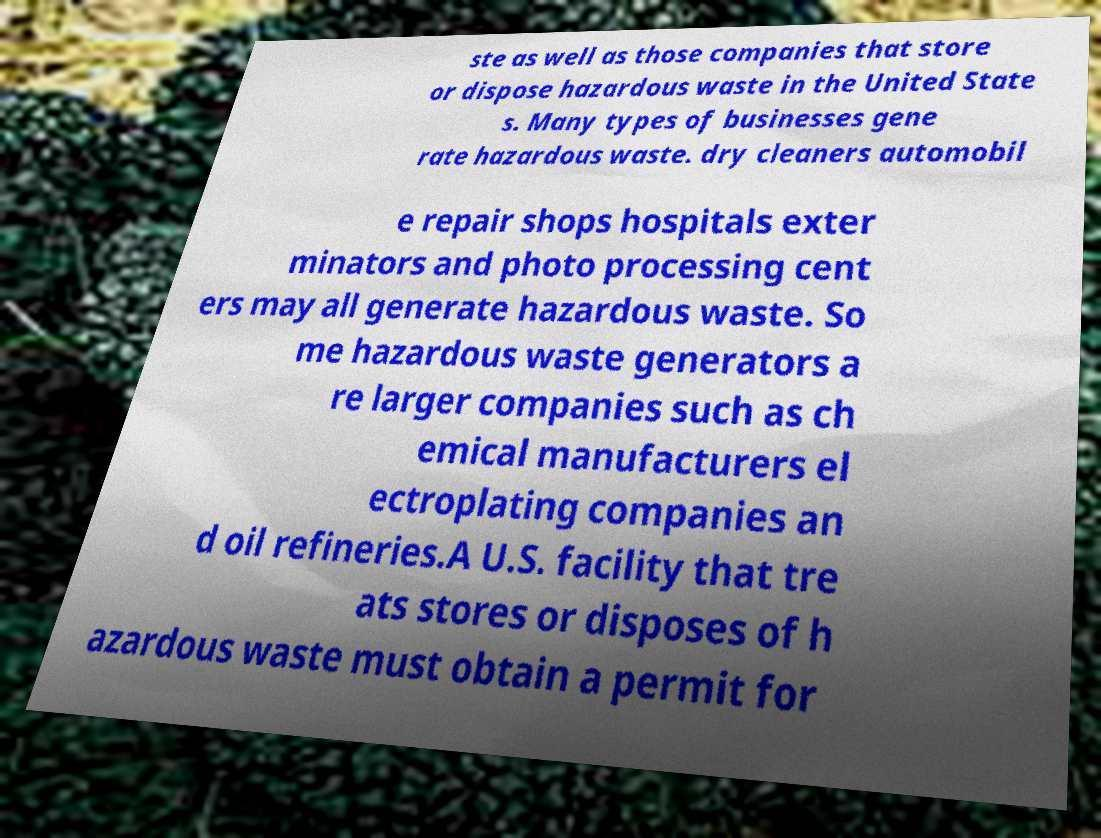Can you accurately transcribe the text from the provided image for me? ste as well as those companies that store or dispose hazardous waste in the United State s. Many types of businesses gene rate hazardous waste. dry cleaners automobil e repair shops hospitals exter minators and photo processing cent ers may all generate hazardous waste. So me hazardous waste generators a re larger companies such as ch emical manufacturers el ectroplating companies an d oil refineries.A U.S. facility that tre ats stores or disposes of h azardous waste must obtain a permit for 